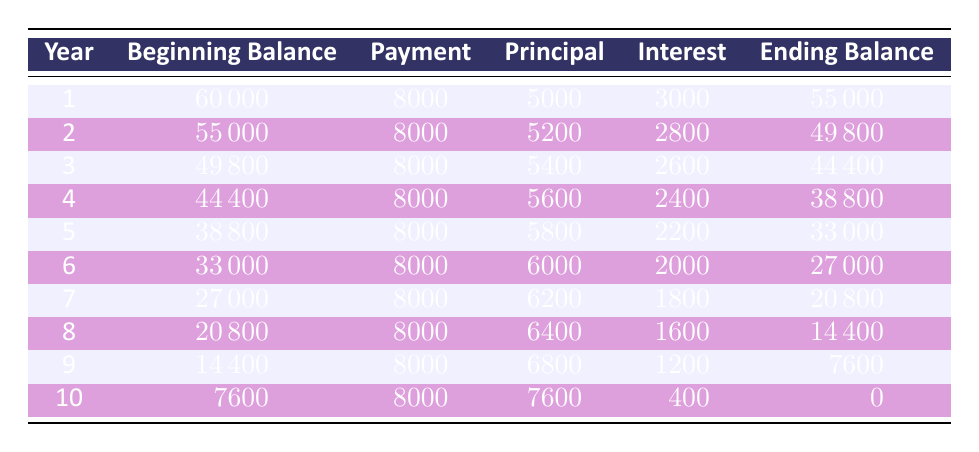What is the total finance amount for the equipment purchase? The table states that the finance amount is explicitly provided as 60000.
Answer: 60000 What was the ending balance after year 4? From the table, the ending balance for year 4 is listed as 38800.
Answer: 38800 What is the total principal payment made over the 10 years? To find the total principal payment, add the principal payments from each year: 5000 + 5200 + 5400 + 5600 + 5800 + 6000 + 6200 + 6400 + 6800 + 7600 = 55000.
Answer: 55000 Is the interest payment in year 5 greater than in year 6? According to the table, the interest payment in year 5 is 2200 and in year 6 is 2000, therefore, the interest payment in year 5 is greater.
Answer: Yes In which year was the highest principal payment made, and what was the amount? By examining the table, the highest principal payment occurred in year 10, which was 7600.
Answer: Year 10, 7600 What is the average annual payment made over the duration of the loan? The total payment over 10 years is 8000 for each year, hence 80000 in total. Dividing by 10 gives an average of 8000 per year.
Answer: 8000 How much interest was paid in the last year compared to the first year? In year 1, the interest payment was 3000, and in year 10, it was 400. Therefore, the last year's payment is significantly lower by subtracting: 3000 - 400 = 2600, indicating a drop.
Answer: The difference is 2600 Did the beginning balance decrease consistently every year? Observing the beginning balances, they are indeed decreasing each year: 60000, 55000, 49800, etc. This shows a consistent decline.
Answer: Yes What was the total interest paid over the entire amortization period? The total interest paid is the sum of interest payments over 10 years, calculated as 3000 + 2800 + 2600 + 2400 + 2200 + 2000 + 1800 + 1600 + 1200 + 400 = 19400.
Answer: 19400 